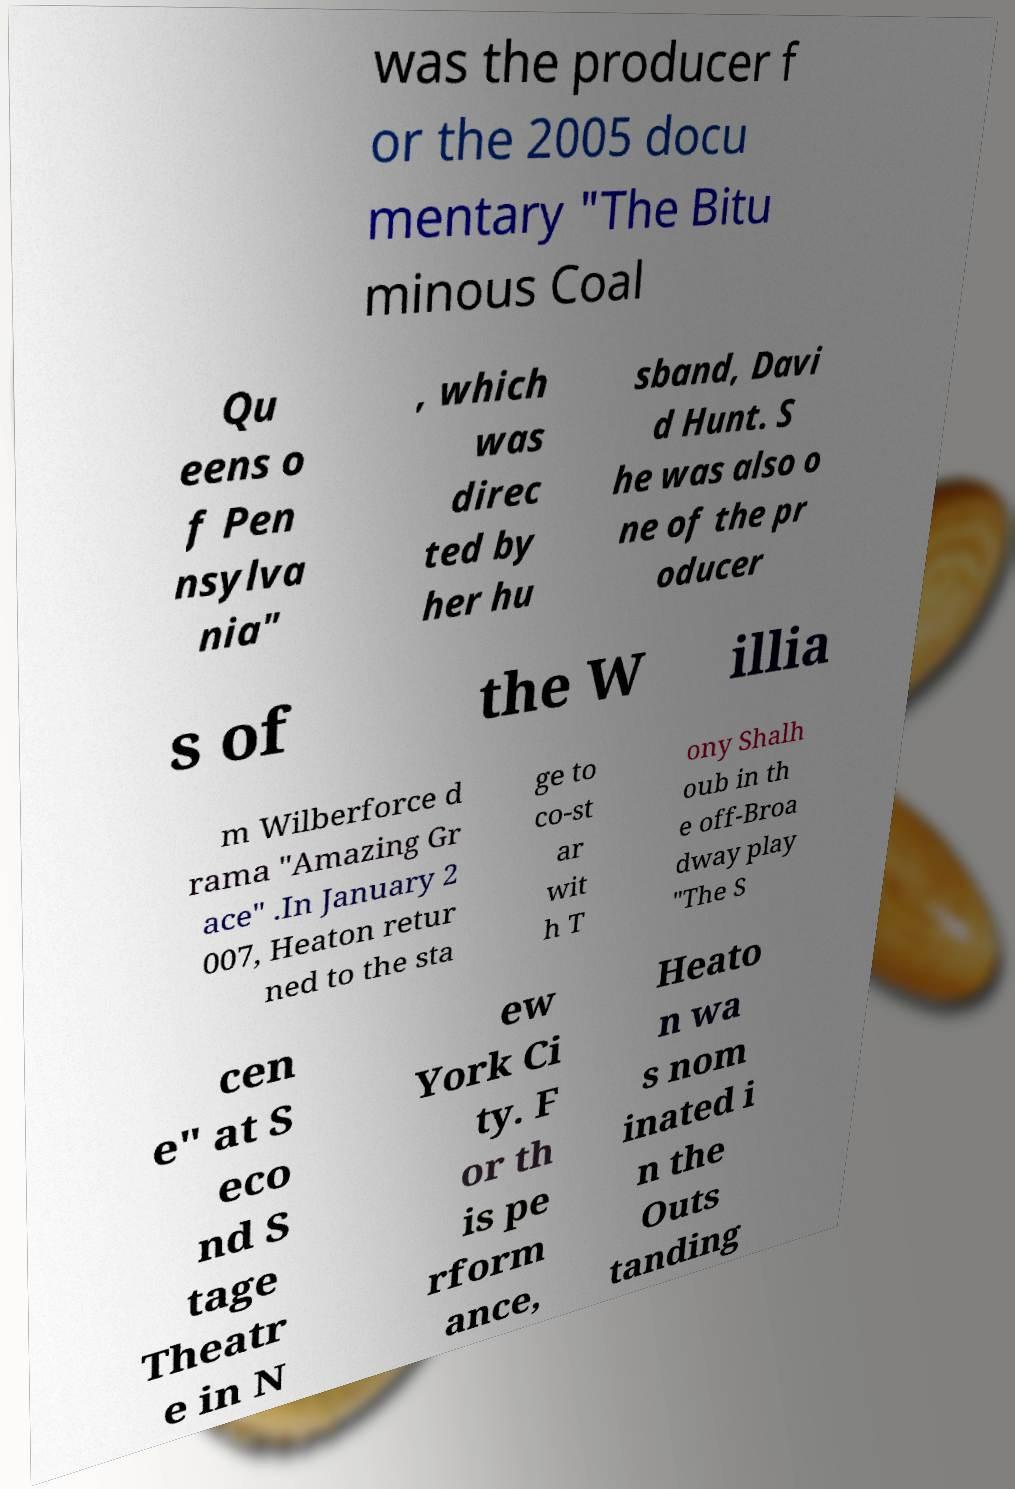Could you extract and type out the text from this image? was the producer f or the 2005 docu mentary "The Bitu minous Coal Qu eens o f Pen nsylva nia" , which was direc ted by her hu sband, Davi d Hunt. S he was also o ne of the pr oducer s of the W illia m Wilberforce d rama "Amazing Gr ace" .In January 2 007, Heaton retur ned to the sta ge to co-st ar wit h T ony Shalh oub in th e off-Broa dway play "The S cen e" at S eco nd S tage Theatr e in N ew York Ci ty. F or th is pe rform ance, Heato n wa s nom inated i n the Outs tanding 